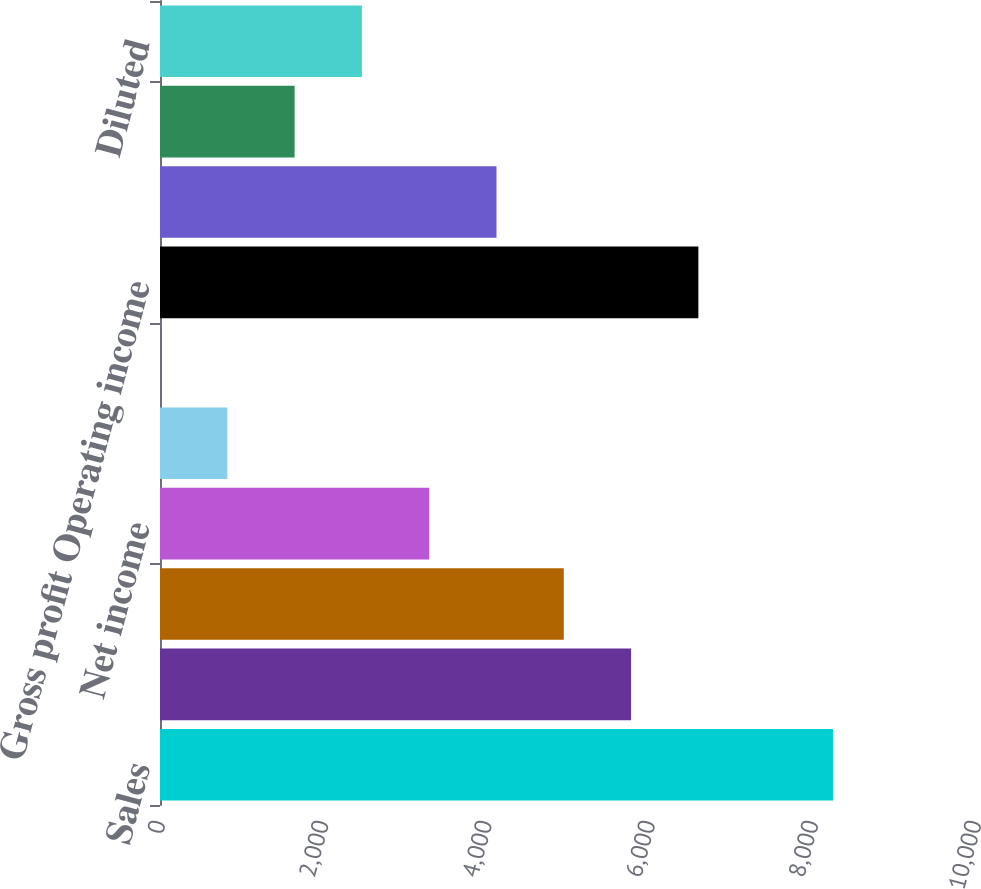<chart> <loc_0><loc_0><loc_500><loc_500><bar_chart><fcel>Sales<fcel>Gross profit<fcel>Operating income<fcel>Net income<fcel>Class A Basic<fcel>Class B Basic Diluted<fcel>Gross profit Operating income<fcel>Net income Net income<fcel>Class B Basic<fcel>Diluted<nl><fcel>8247<fcel>5773.03<fcel>4948.38<fcel>3299.08<fcel>825.13<fcel>0.48<fcel>6597.68<fcel>4123.73<fcel>1649.78<fcel>2474.43<nl></chart> 